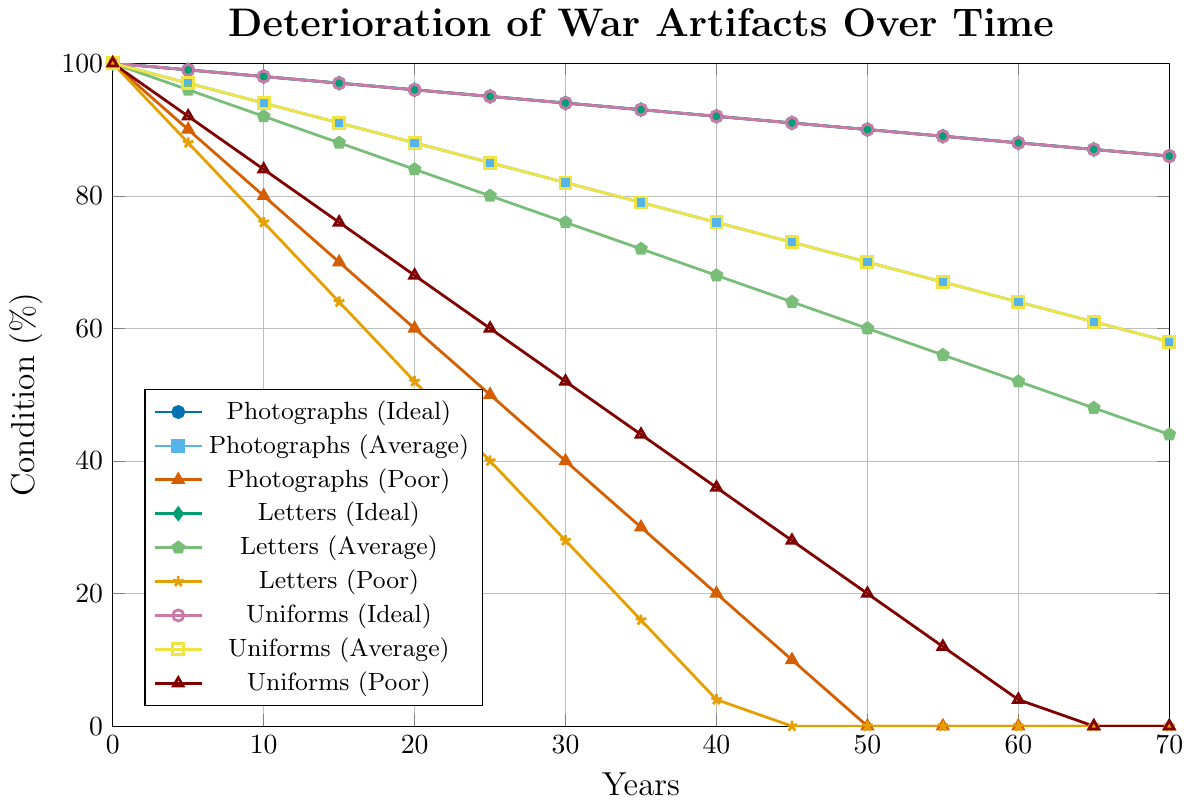What is the deteriorative condition of photographs in average storage conditions at 10 years? To find the answer, look at the line marked for "Photographs (Average)" and find the y-value corresponding to 10 years on the x-axis.
Answer: 94 What is the difference in the deteriorative condition of letters in ideal storage conditions between 0 and 50 years? Look at the line marked for "Letters (Ideal)" and check the y-values corresponding to 0 and 50 years. Subtract the y-value at 50 years from the y-value at 0 years: 100 - 90.
Answer: 10 Which artifact type in poor storage conditions deteriorates completely first, and in how many years? To determine this, find the artifact type with the y-value reaching 0% the earliest in the poor storage conditions. All artifact types except "Letters (Poor)" and "Photographs (Poor)" have some deterioration rate even after 70 years. "Letters (Poor)" hits 0% at 45 years.
Answer: Letters, 45 years How much greater is the deterioration of uniforms in poor storage conditions compared to average storage conditions at 30 years? Check the y-values for "Uniforms (Poor)" and "Uniforms (Average)" at 30 years. Subtract the y-value for average conditions from the y-value for poor conditions: 82 - 52.
Answer: 30 At what year do all artifacts in ideal storage conditions retain over 90% of their condition? For this, find the year after which all artifact types listed under ideal conditions drop below 90%. It appears that all ideal lines are above 90% at up to and including 45 years.
Answer: 45 How do the deterioration rates of photographs and letters in poor storage conditions compare at 20 years? For this, compare the y-values of "Photographs (Poor)" and "Letters (Poor)" at 20 years. The y-value for "Photographs (Poor)" is 60%, while for "Letters (Poor)" it’s 52%.
Answer: Photographs deteriorate less; 60% vs 52% Which artifact type in average storage conditions shows the steepest decline between 0 to 70 years? This requires comparing the overall y-values' decline from 100% to the respective end values for each artifact type in average storage conditions. "Letters (Average)" declines from 100% to 44%, the steepest decline among the average condition lines.
Answer: Letters At what rate does the condition of letters deteriorate in poor storage conditions between years 5 and 10? Calculate the difference between the y-values at 5 years and 10 years for "Letters (Poor)" and then divide by the time period (10 - 5): (88 - 76) / 5.
Answer: 2.4% per year 